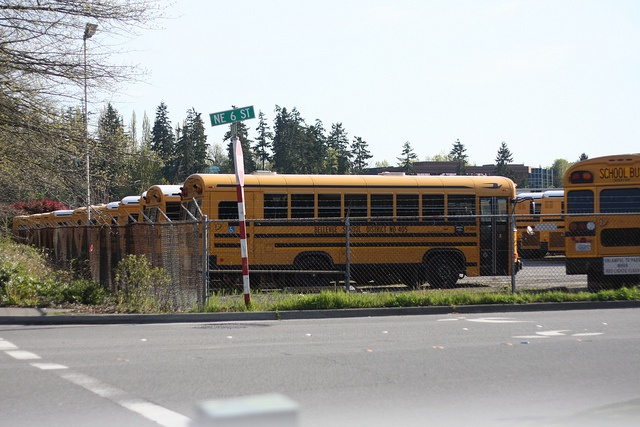Describe the objects in this image and their specific colors. I can see bus in darkgray, black, maroon, and gray tones, bus in darkgray, black, maroon, and gray tones, bus in darkgray, black, brown, and maroon tones, bus in darkgray, black, maroon, and white tones, and bus in darkgray, maroon, black, and gray tones in this image. 